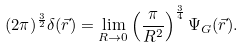<formula> <loc_0><loc_0><loc_500><loc_500>( 2 \pi ) ^ { \frac { 3 } { 2 } } \delta ( \vec { r } ) = \lim _ { R \rightarrow 0 } \left ( \frac { \pi } { R ^ { 2 } } \right ) ^ { \frac { 3 } { 4 } } \Psi _ { G } ( \vec { r } ) .</formula> 